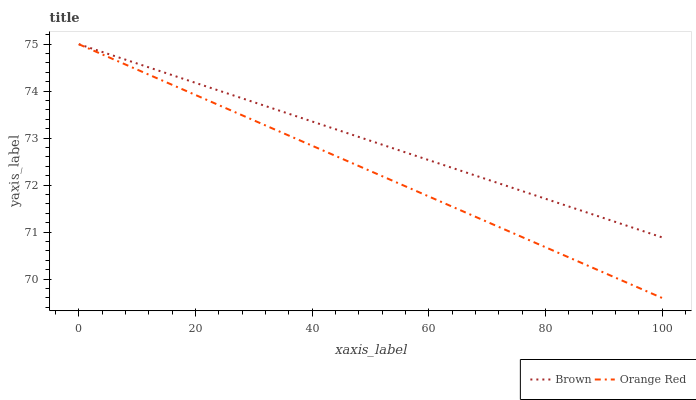Does Orange Red have the minimum area under the curve?
Answer yes or no. Yes. Does Brown have the maximum area under the curve?
Answer yes or no. Yes. Does Orange Red have the maximum area under the curve?
Answer yes or no. No. Is Brown the smoothest?
Answer yes or no. Yes. Is Orange Red the roughest?
Answer yes or no. Yes. Is Orange Red the smoothest?
Answer yes or no. No. 